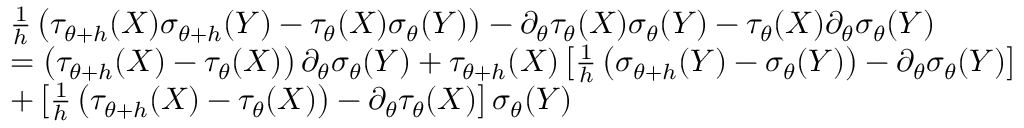<formula> <loc_0><loc_0><loc_500><loc_500>\begin{array} { r l } & { \frac { 1 } { h } \left ( \tau _ { \theta + h } ( X ) \sigma _ { \theta + h } ( Y ) - \tau _ { \theta } ( X ) \sigma _ { \theta } ( Y ) \right ) - \partial _ { \theta } \tau _ { \theta } ( X ) \sigma _ { \theta } ( Y ) - \tau _ { \theta } ( X ) \partial _ { \theta } \sigma _ { \theta } ( Y ) } \\ & { = \left ( \tau _ { \theta + h } ( X ) - \tau _ { \theta } ( X ) \right ) \partial _ { \theta } \sigma _ { \theta } ( Y ) + \tau _ { \theta + h } ( X ) \left [ \frac { 1 } { h } \left ( \sigma _ { \theta + h } ( Y ) - \sigma _ { \theta } ( Y ) \right ) - \partial _ { \theta } \sigma _ { \theta } ( Y ) \right ] } \\ & { + \left [ \frac { 1 } { h } \left ( \tau _ { \theta + h } ( X ) - \tau _ { \theta } ( X ) \right ) - \partial _ { \theta } \tau _ { \theta } ( X ) \right ] \sigma _ { \theta } ( Y ) } \end{array}</formula> 